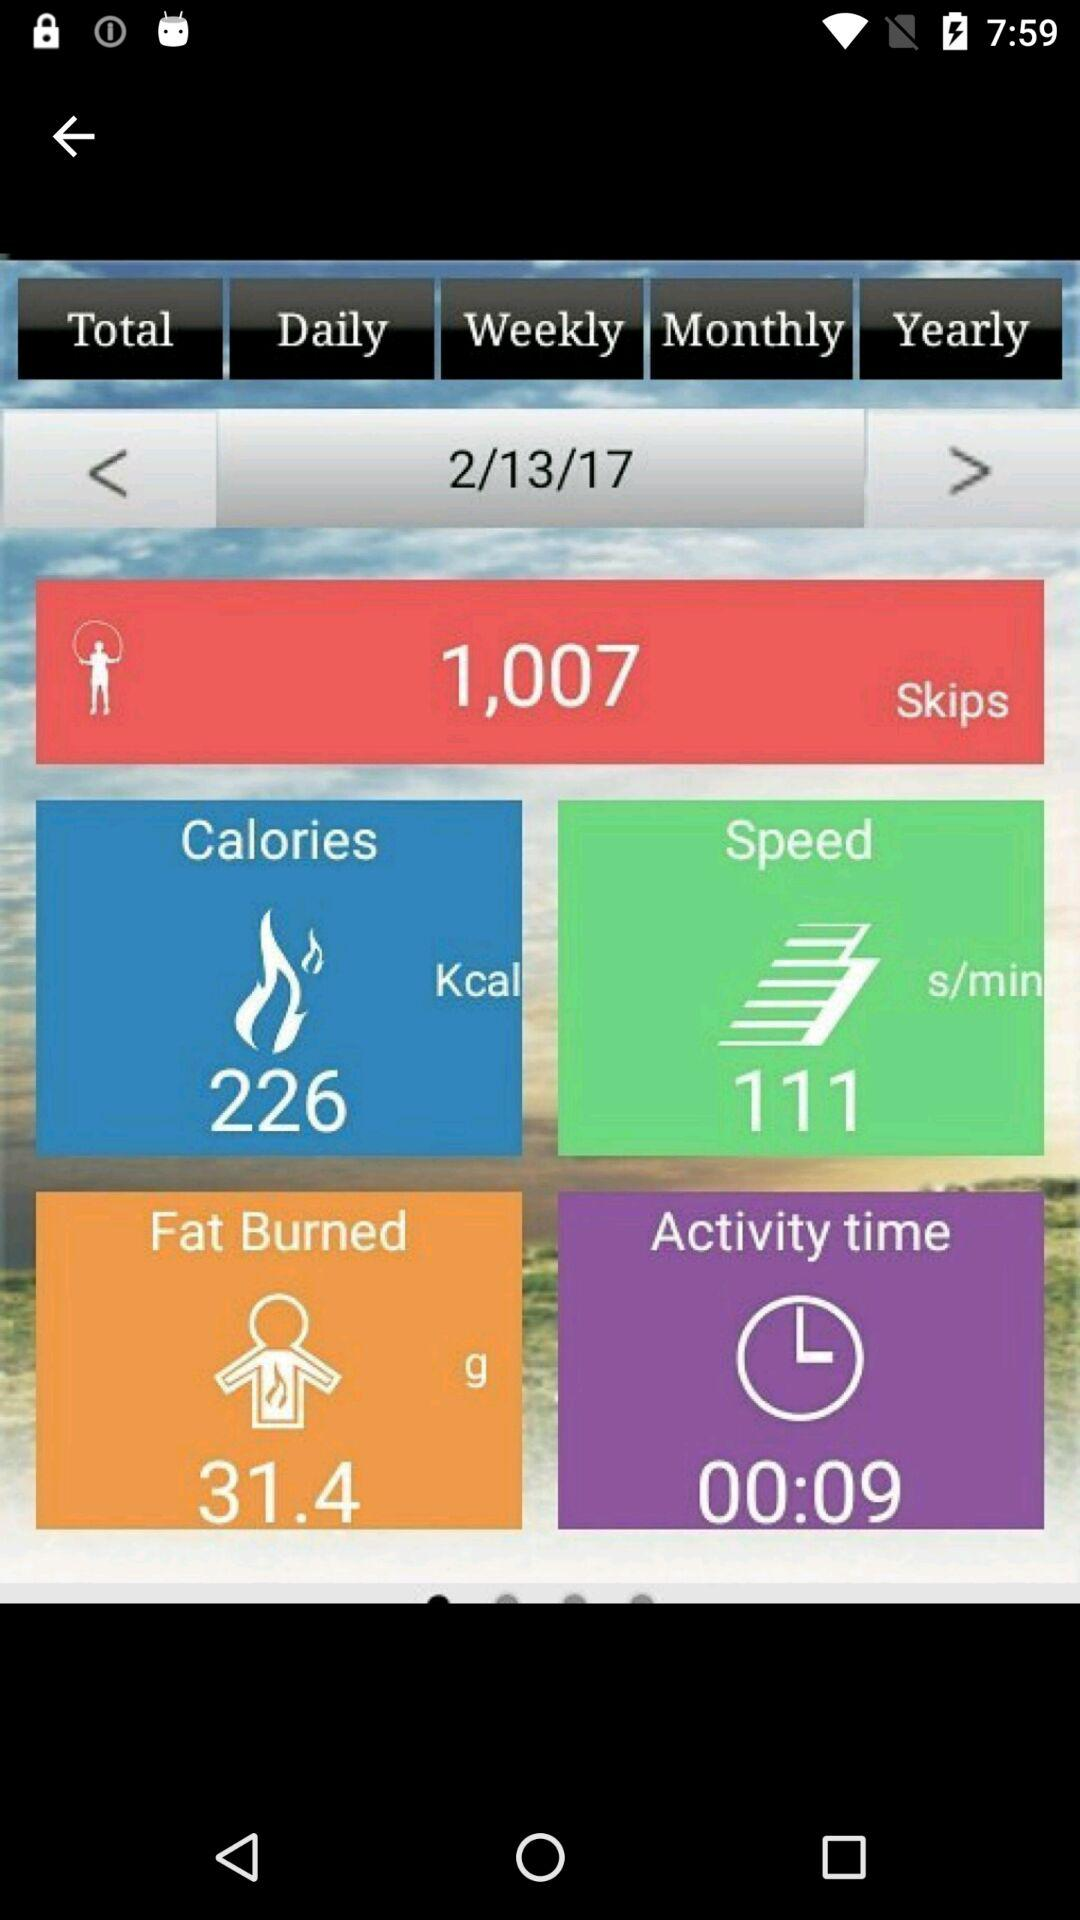How much fat and calories were burned on 2/13/17? The burned fat and calories are 31.4 g and 226 kcal respectively. 